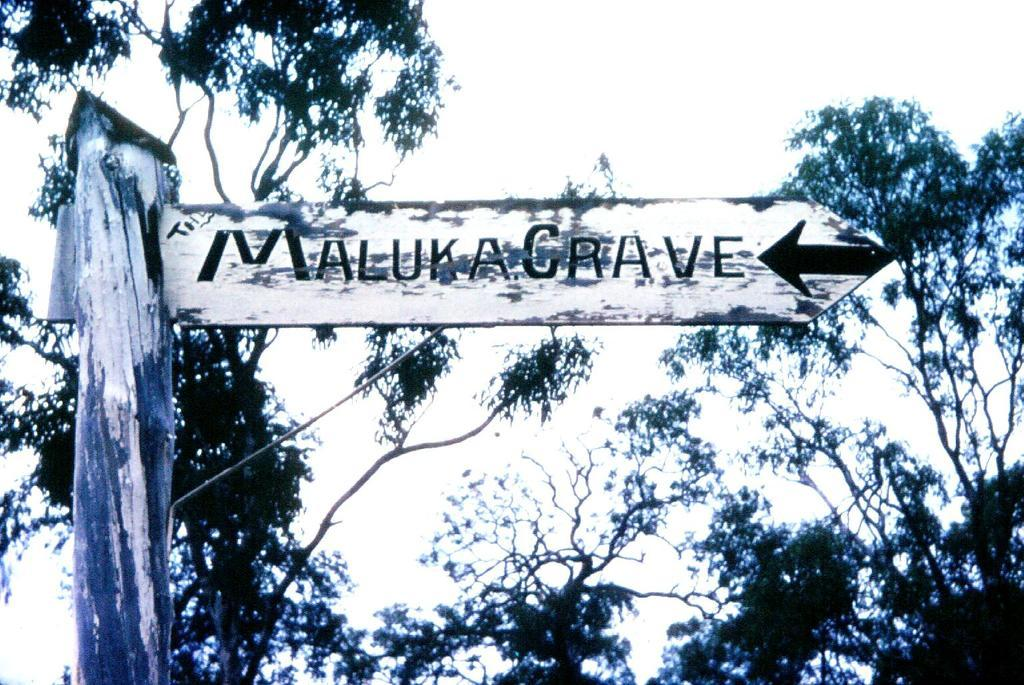What is located in the center of the image? There is a pole and a sign board in the center of the image. What can be seen in the background of the image? The sky, clouds, and trees are visible in the background of the image. How many apples are hanging from the pole in the image? There are no apples present in the image. Can you see any babies playing near the pole in the image? There are no babies present in the image. 